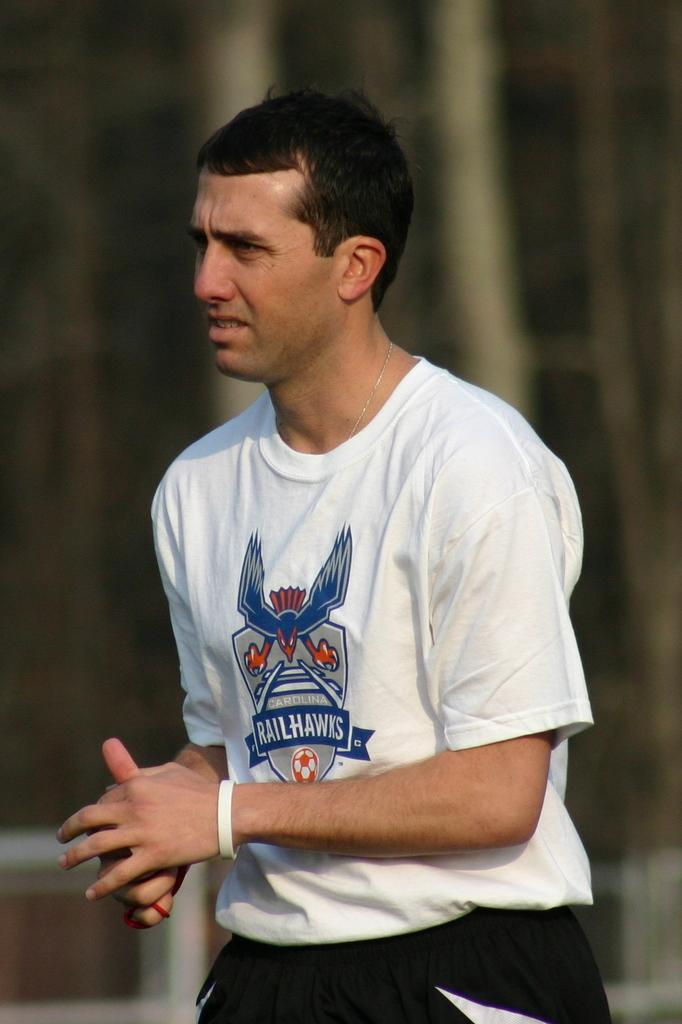Provide a one-sentence caption for the provided image. A white man with brown hair wearing a Carolina Railhawks white tshirt. 